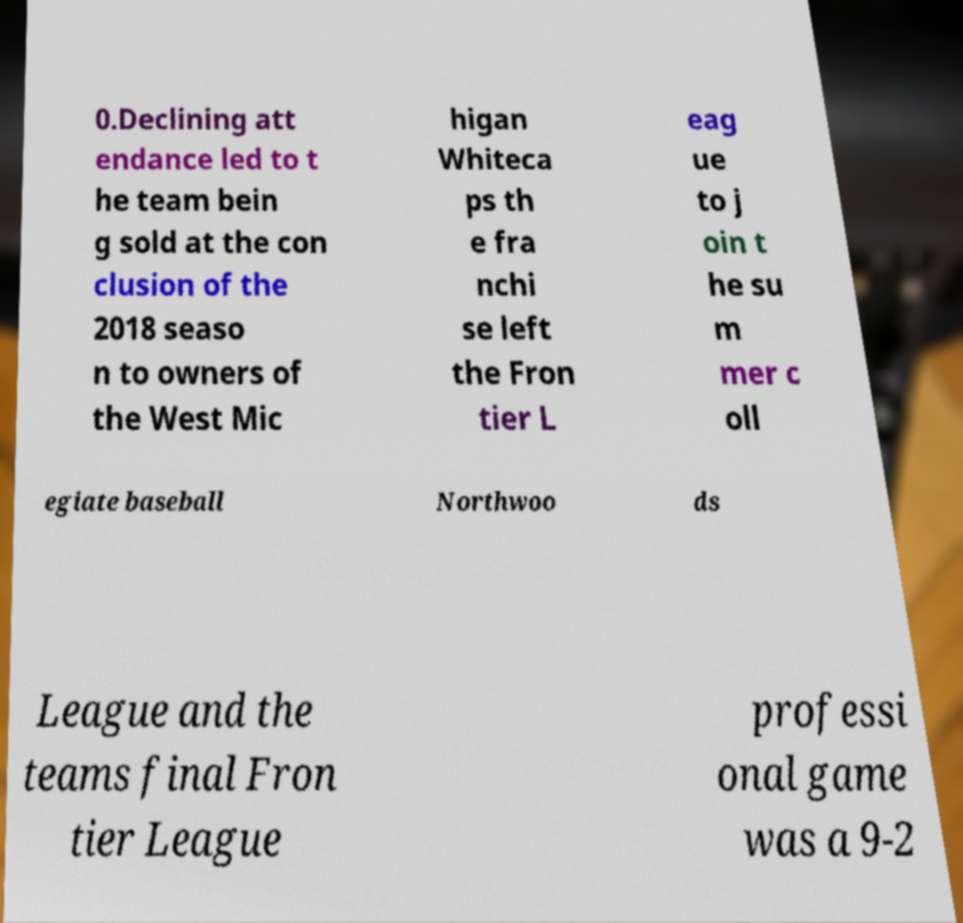I need the written content from this picture converted into text. Can you do that? 0.Declining att endance led to t he team bein g sold at the con clusion of the 2018 seaso n to owners of the West Mic higan Whiteca ps th e fra nchi se left the Fron tier L eag ue to j oin t he su m mer c oll egiate baseball Northwoo ds League and the teams final Fron tier League professi onal game was a 9-2 